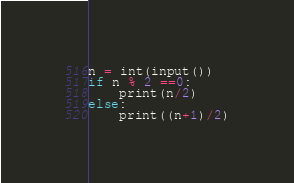<code> <loc_0><loc_0><loc_500><loc_500><_Python_>n = int(input())
if n % 2 ==0:
    print(n/2)
else:
    print((n+1)/2)</code> 